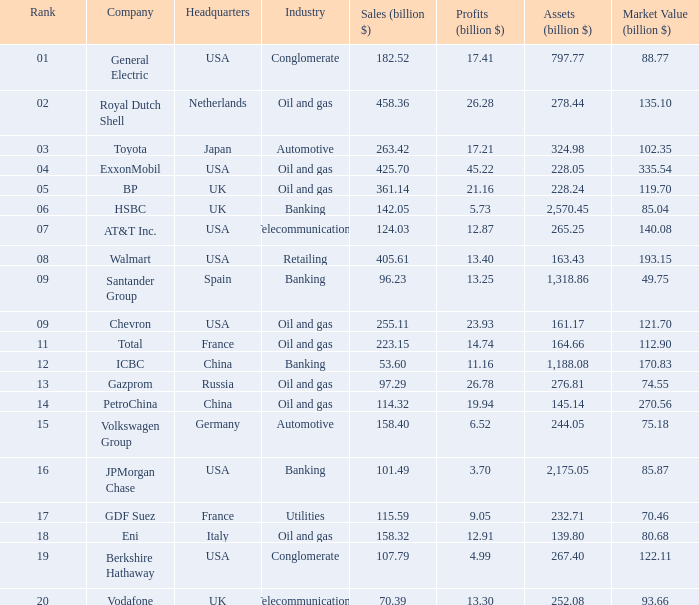What quantity of assets (billion $) is owned by an oil and gas industry having a rank of 9 and a market value (billion $) surpassing 12 None. 